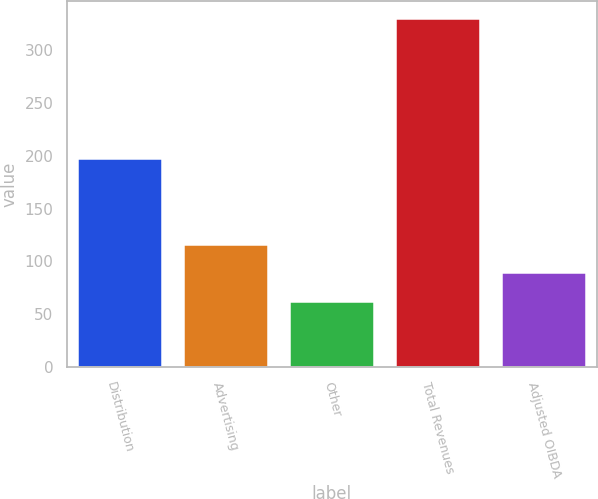Convert chart. <chart><loc_0><loc_0><loc_500><loc_500><bar_chart><fcel>Distribution<fcel>Advertising<fcel>Other<fcel>Total Revenues<fcel>Adjusted OIBDA<nl><fcel>198<fcel>116.4<fcel>63<fcel>330<fcel>89.7<nl></chart> 